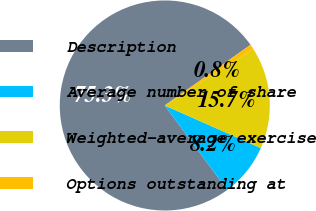Convert chart. <chart><loc_0><loc_0><loc_500><loc_500><pie_chart><fcel>Description<fcel>Average number of share<fcel>Weighted-average exercise<fcel>Options outstanding at<nl><fcel>75.34%<fcel>8.22%<fcel>15.68%<fcel>0.76%<nl></chart> 